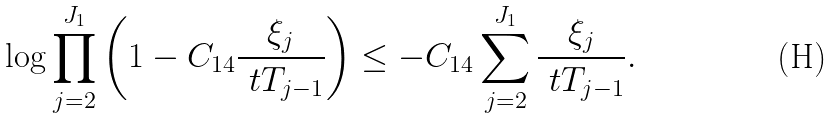Convert formula to latex. <formula><loc_0><loc_0><loc_500><loc_500>\log \prod _ { j = 2 } ^ { J _ { 1 } } \left ( 1 - C _ { 1 4 } \frac { \xi _ { j } } { \ t T _ { j - 1 } } \right ) \leq - C _ { 1 4 } \sum _ { j = 2 } ^ { J _ { 1 } } \frac { \xi _ { j } } { \ t T _ { j - 1 } } .</formula> 